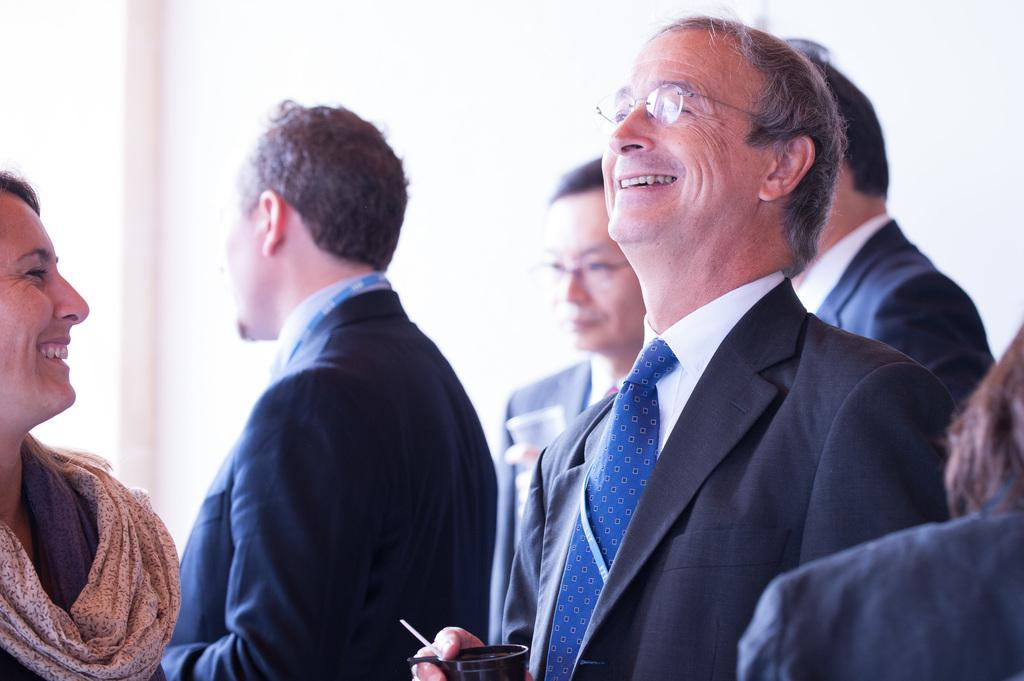What is happening in the image involving a group of people? There is a group of people standing over a place in the image. How are the people in the front of the group depicted? The people in the front are smiling, and one of them is holding a cup in his hand. Can you describe the overall mood or expression of the people in the image? The smiling people in the front suggest a positive or happy mood. What type of feather can be seen on the ground in the image? There is no feather present on the ground in the image. 